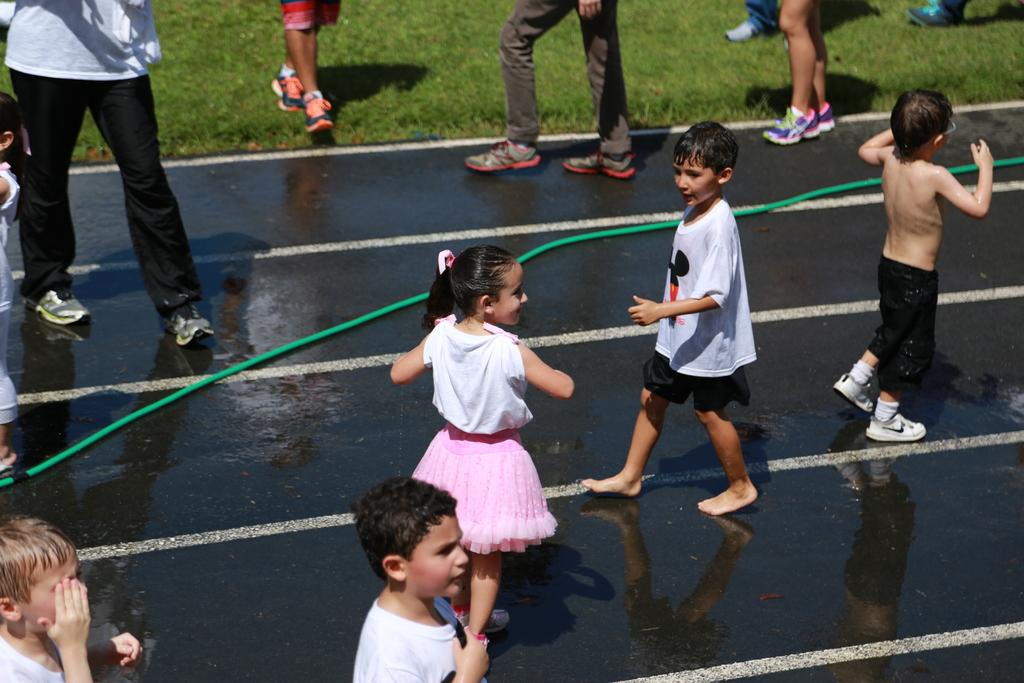What can be observed about the people in the image? There are people standing in the image, including boys and a girl. What is the ground surface like in the image? There is grass on the ground in the image. Are there any objects or structures visible in the image? Yes, there is a water pipe in the image. What type of test is being conducted by the doctor in the image? There is no doctor or test present in the image; it features people standing on grass with a water pipe nearby. Can you tell me how many giraffes are visible in the image? There are no giraffes present in the image. 